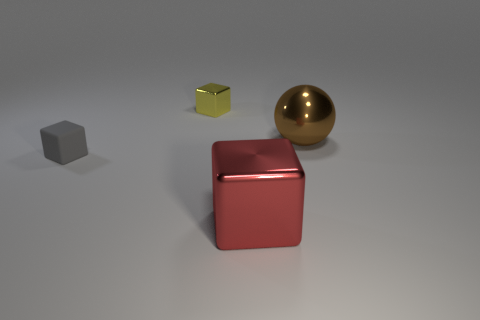Subtract all metal cubes. How many cubes are left? 1 Add 4 small cubes. How many objects exist? 8 Subtract all blocks. How many objects are left? 1 Add 2 tiny shiny blocks. How many tiny shiny blocks are left? 3 Add 2 small matte cubes. How many small matte cubes exist? 3 Subtract 0 green cylinders. How many objects are left? 4 Subtract all large objects. Subtract all brown spheres. How many objects are left? 1 